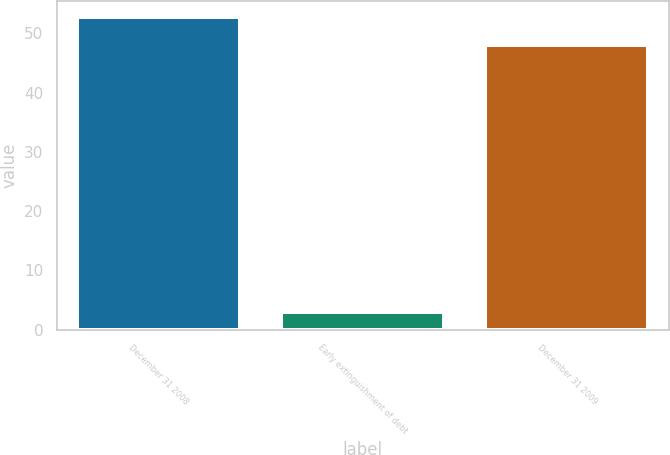Convert chart to OTSL. <chart><loc_0><loc_0><loc_500><loc_500><bar_chart><fcel>December 31 2008<fcel>Early extinguishment of debt<fcel>December 31 2009<nl><fcel>52.8<fcel>3<fcel>48<nl></chart> 